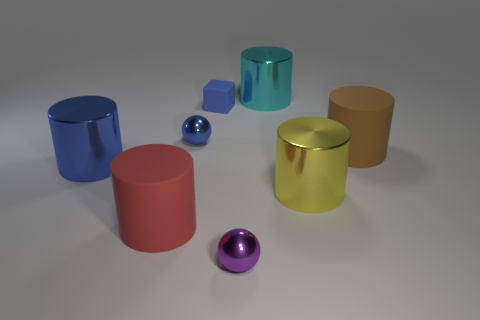What time of day does the lighting in the scene suggest? The lighting in the scene is neutral and appears to be artificial, suggesting an indoor setting where the time of day is not indicated by the lighting. 